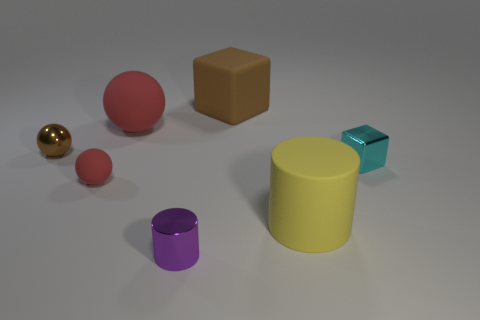Add 2 tiny brown shiny things. How many objects exist? 9 Subtract all balls. How many objects are left? 4 Add 2 big green objects. How many big green objects exist? 2 Subtract 0 gray cylinders. How many objects are left? 7 Subtract all matte cylinders. Subtract all brown cubes. How many objects are left? 5 Add 1 big rubber spheres. How many big rubber spheres are left? 2 